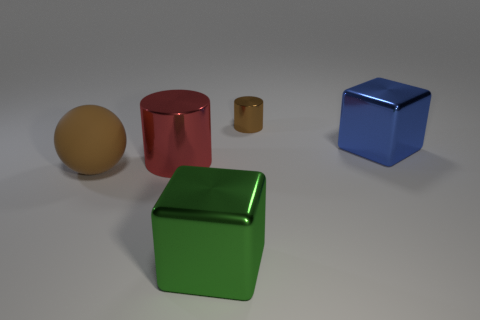Add 1 green shiny balls. How many objects exist? 6 Subtract all cylinders. How many objects are left? 3 Subtract all cyan cubes. Subtract all purple cylinders. How many cubes are left? 2 Subtract all red metallic cylinders. Subtract all large matte objects. How many objects are left? 3 Add 5 big red metallic objects. How many big red metallic objects are left? 6 Add 3 large red metallic cylinders. How many large red metallic cylinders exist? 4 Subtract 0 blue balls. How many objects are left? 5 